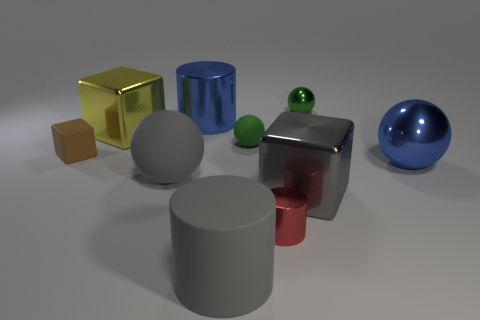What size is the ball that is on the right side of the gray cylinder and left of the large gray metallic object?
Ensure brevity in your answer.  Small. How many other things are there of the same shape as the large yellow thing?
Your answer should be very brief. 2. How many big gray objects are to the left of the gray block?
Your answer should be compact. 2. Is the number of big gray matte things that are behind the green rubber object less than the number of small green rubber objects that are behind the green metal thing?
Offer a very short reply. No. There is a tiny green object that is in front of the large blue metal object to the left of the blue object that is right of the rubber cylinder; what is its shape?
Give a very brief answer. Sphere. What shape is the big thing that is both to the right of the yellow metal thing and behind the tiny green matte ball?
Offer a very short reply. Cylinder. Are there any big blue spheres made of the same material as the tiny brown cube?
Offer a very short reply. No. What size is the matte cylinder that is the same color as the big matte sphere?
Your answer should be compact. Large. What is the color of the big shiny block that is to the left of the small red metallic object?
Your answer should be very brief. Yellow. There is a brown object; does it have the same shape as the big blue object that is on the left side of the gray cylinder?
Your answer should be compact. No. 